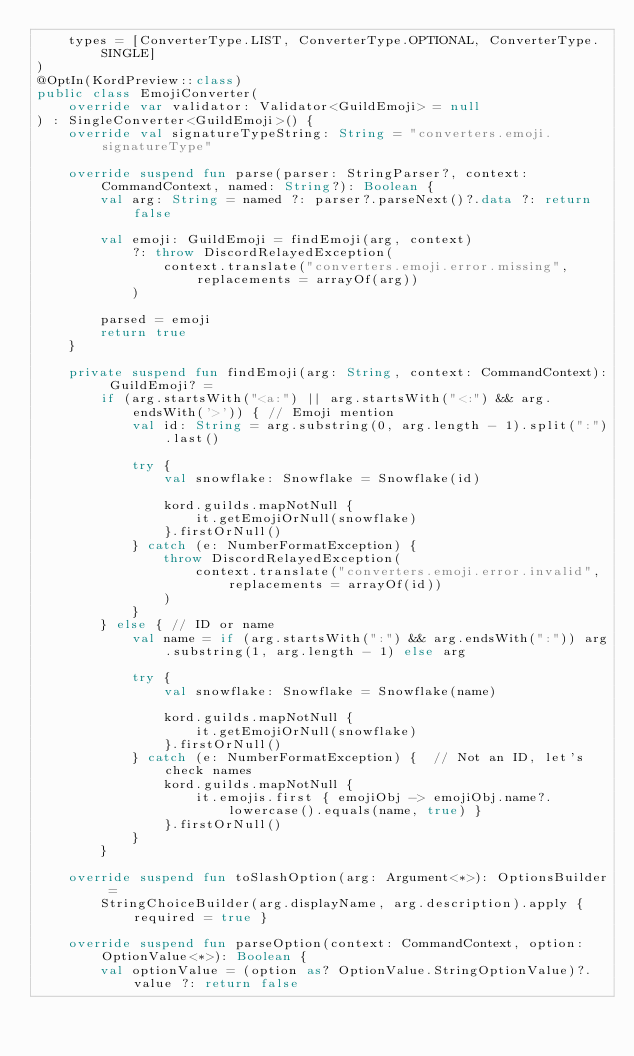<code> <loc_0><loc_0><loc_500><loc_500><_Kotlin_>    types = [ConverterType.LIST, ConverterType.OPTIONAL, ConverterType.SINGLE]
)
@OptIn(KordPreview::class)
public class EmojiConverter(
    override var validator: Validator<GuildEmoji> = null
) : SingleConverter<GuildEmoji>() {
    override val signatureTypeString: String = "converters.emoji.signatureType"

    override suspend fun parse(parser: StringParser?, context: CommandContext, named: String?): Boolean {
        val arg: String = named ?: parser?.parseNext()?.data ?: return false

        val emoji: GuildEmoji = findEmoji(arg, context)
            ?: throw DiscordRelayedException(
                context.translate("converters.emoji.error.missing", replacements = arrayOf(arg))
            )

        parsed = emoji
        return true
    }

    private suspend fun findEmoji(arg: String, context: CommandContext): GuildEmoji? =
        if (arg.startsWith("<a:") || arg.startsWith("<:") && arg.endsWith('>')) { // Emoji mention
            val id: String = arg.substring(0, arg.length - 1).split(":").last()

            try {
                val snowflake: Snowflake = Snowflake(id)

                kord.guilds.mapNotNull {
                    it.getEmojiOrNull(snowflake)
                }.firstOrNull()
            } catch (e: NumberFormatException) {
                throw DiscordRelayedException(
                    context.translate("converters.emoji.error.invalid", replacements = arrayOf(id))
                )
            }
        } else { // ID or name
            val name = if (arg.startsWith(":") && arg.endsWith(":")) arg.substring(1, arg.length - 1) else arg

            try {
                val snowflake: Snowflake = Snowflake(name)

                kord.guilds.mapNotNull {
                    it.getEmojiOrNull(snowflake)
                }.firstOrNull()
            } catch (e: NumberFormatException) {  // Not an ID, let's check names
                kord.guilds.mapNotNull {
                    it.emojis.first { emojiObj -> emojiObj.name?.lowercase().equals(name, true) }
                }.firstOrNull()
            }
        }

    override suspend fun toSlashOption(arg: Argument<*>): OptionsBuilder =
        StringChoiceBuilder(arg.displayName, arg.description).apply { required = true }

    override suspend fun parseOption(context: CommandContext, option: OptionValue<*>): Boolean {
        val optionValue = (option as? OptionValue.StringOptionValue)?.value ?: return false
</code> 